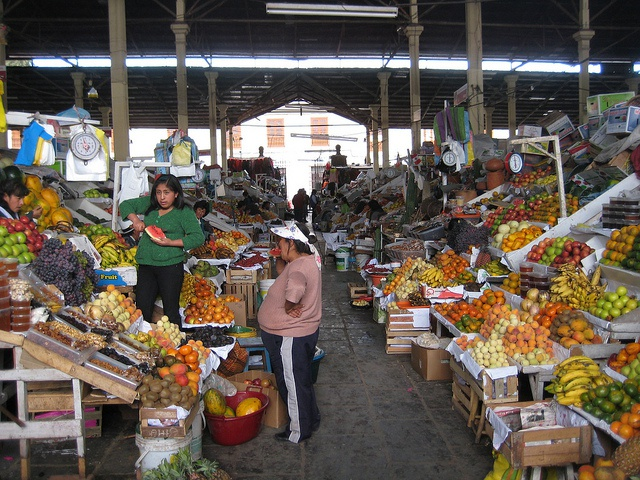Describe the objects in this image and their specific colors. I can see people in black, gray, and darkgray tones, people in black, darkgreen, and brown tones, banana in black, olive, and maroon tones, apple in black, maroon, olive, and brown tones, and people in black, brown, and maroon tones in this image. 